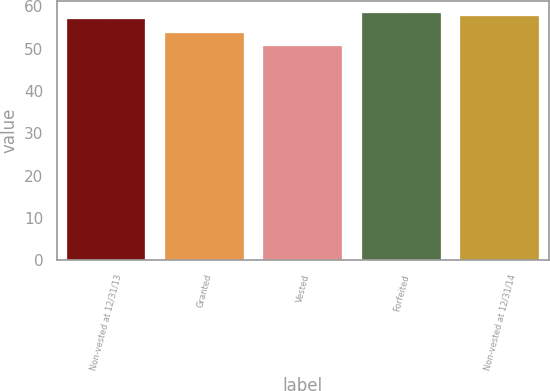<chart> <loc_0><loc_0><loc_500><loc_500><bar_chart><fcel>Non-vested at 12/31/13<fcel>Granted<fcel>Vested<fcel>Forfeited<fcel>Non-vested at 12/31/14<nl><fcel>56.93<fcel>53.65<fcel>50.75<fcel>58.43<fcel>57.68<nl></chart> 